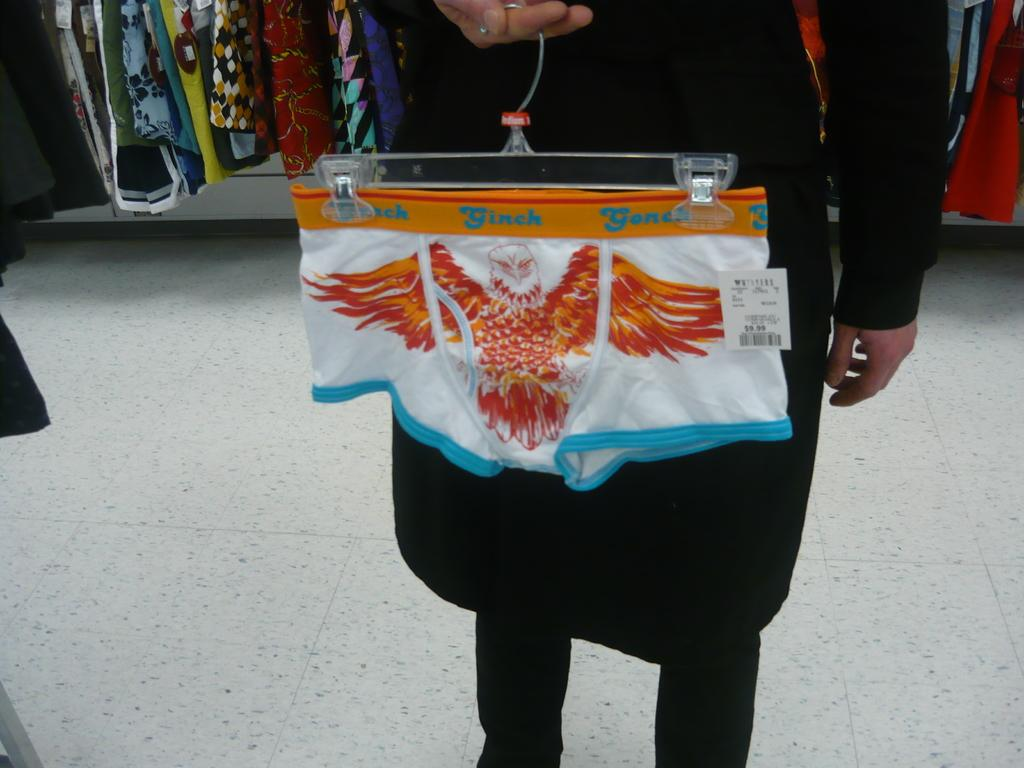Who is present in the image? There is a person in the image. What is the person wearing? The person is wearing a black dress. What is the person holding in the image? The person is holding a hanger. What can be seen on the left side of the image? There are clothes on the left side of the image. What type of creature is hiding under the floor in the image? There is no creature hiding under the floor in the image, as the floor is not mentioned or visible in the provided facts. 